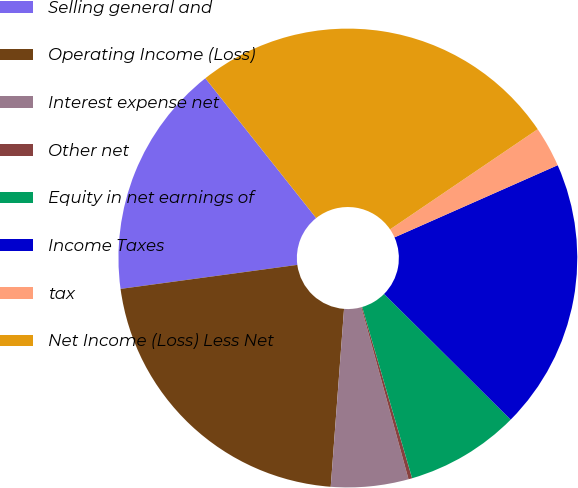Convert chart. <chart><loc_0><loc_0><loc_500><loc_500><pie_chart><fcel>Selling general and<fcel>Operating Income (Loss)<fcel>Interest expense net<fcel>Other net<fcel>Equity in net earnings of<fcel>Income Taxes<fcel>tax<fcel>Net Income (Loss) Less Net<nl><fcel>16.48%<fcel>21.66%<fcel>5.45%<fcel>0.26%<fcel>8.04%<fcel>19.07%<fcel>2.86%<fcel>26.18%<nl></chart> 